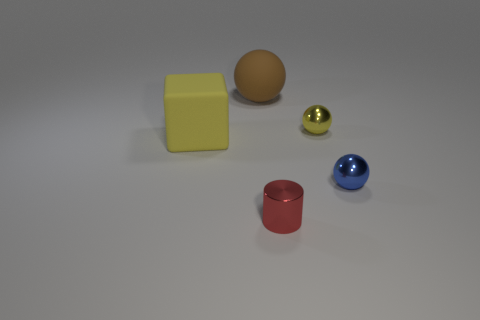Subtract all small metal spheres. How many spheres are left? 1 Add 4 big brown things. How many objects exist? 9 Subtract all large yellow shiny cylinders. Subtract all large rubber cubes. How many objects are left? 4 Add 4 big brown objects. How many big brown objects are left? 5 Add 4 large yellow matte blocks. How many large yellow matte blocks exist? 5 Subtract all brown balls. How many balls are left? 2 Subtract 1 brown balls. How many objects are left? 4 Subtract all cylinders. How many objects are left? 4 Subtract 1 cylinders. How many cylinders are left? 0 Subtract all cyan balls. Subtract all brown cylinders. How many balls are left? 3 